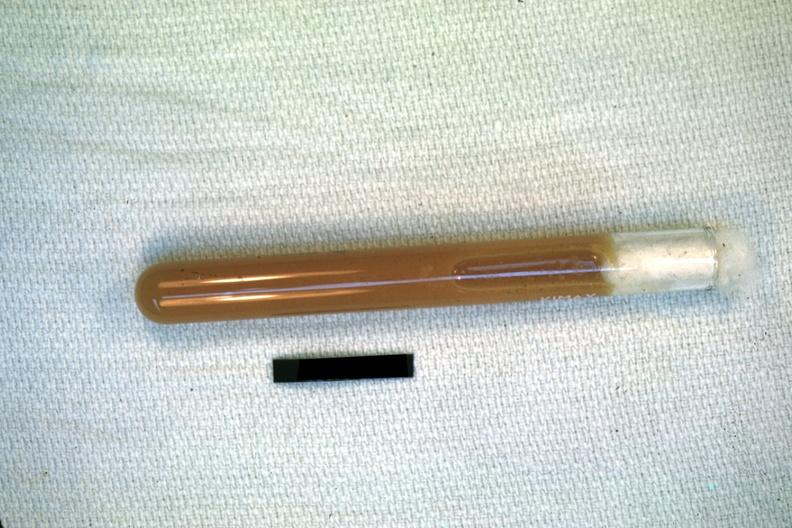does case of peritonitis slide show case of peritonitis slide illustrates pus from the peritoneal cavity?
Answer the question using a single word or phrase. No 